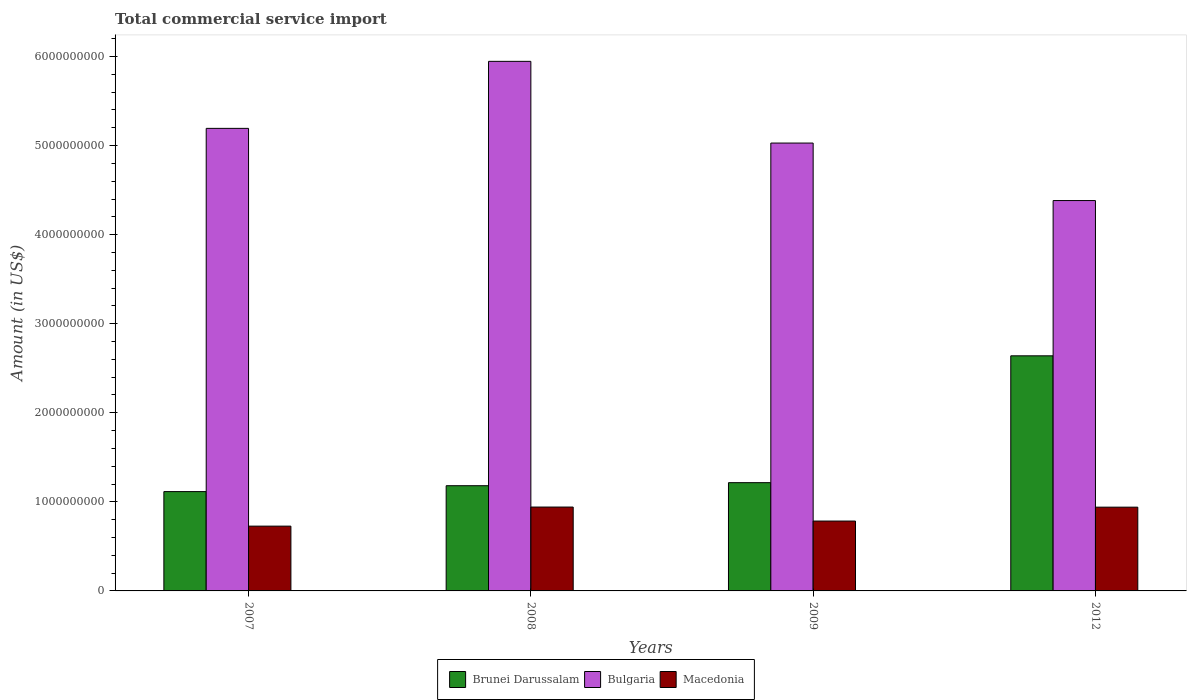Are the number of bars per tick equal to the number of legend labels?
Ensure brevity in your answer.  Yes. How many bars are there on the 3rd tick from the left?
Give a very brief answer. 3. What is the total commercial service import in Brunei Darussalam in 2007?
Ensure brevity in your answer.  1.12e+09. Across all years, what is the maximum total commercial service import in Bulgaria?
Your answer should be compact. 5.95e+09. Across all years, what is the minimum total commercial service import in Macedonia?
Offer a terse response. 7.27e+08. What is the total total commercial service import in Macedonia in the graph?
Offer a very short reply. 3.39e+09. What is the difference between the total commercial service import in Bulgaria in 2009 and that in 2012?
Your response must be concise. 6.45e+08. What is the difference between the total commercial service import in Macedonia in 2007 and the total commercial service import in Brunei Darussalam in 2009?
Your answer should be very brief. -4.88e+08. What is the average total commercial service import in Brunei Darussalam per year?
Your response must be concise. 1.54e+09. In the year 2009, what is the difference between the total commercial service import in Brunei Darussalam and total commercial service import in Macedonia?
Your response must be concise. 4.31e+08. In how many years, is the total commercial service import in Macedonia greater than 4800000000 US$?
Ensure brevity in your answer.  0. What is the ratio of the total commercial service import in Bulgaria in 2007 to that in 2012?
Keep it short and to the point. 1.18. What is the difference between the highest and the second highest total commercial service import in Brunei Darussalam?
Make the answer very short. 1.42e+09. What is the difference between the highest and the lowest total commercial service import in Macedonia?
Ensure brevity in your answer.  2.14e+08. What does the 1st bar from the left in 2009 represents?
Your response must be concise. Brunei Darussalam. What does the 1st bar from the right in 2012 represents?
Provide a short and direct response. Macedonia. How many bars are there?
Give a very brief answer. 12. How many years are there in the graph?
Your answer should be compact. 4. What is the difference between two consecutive major ticks on the Y-axis?
Make the answer very short. 1.00e+09. What is the title of the graph?
Offer a terse response. Total commercial service import. Does "Cameroon" appear as one of the legend labels in the graph?
Give a very brief answer. No. What is the Amount (in US$) in Brunei Darussalam in 2007?
Offer a terse response. 1.12e+09. What is the Amount (in US$) in Bulgaria in 2007?
Keep it short and to the point. 5.19e+09. What is the Amount (in US$) of Macedonia in 2007?
Provide a short and direct response. 7.27e+08. What is the Amount (in US$) in Brunei Darussalam in 2008?
Give a very brief answer. 1.18e+09. What is the Amount (in US$) in Bulgaria in 2008?
Your answer should be very brief. 5.95e+09. What is the Amount (in US$) of Macedonia in 2008?
Provide a succinct answer. 9.42e+08. What is the Amount (in US$) of Brunei Darussalam in 2009?
Offer a very short reply. 1.22e+09. What is the Amount (in US$) in Bulgaria in 2009?
Make the answer very short. 5.03e+09. What is the Amount (in US$) in Macedonia in 2009?
Provide a succinct answer. 7.84e+08. What is the Amount (in US$) in Brunei Darussalam in 2012?
Provide a short and direct response. 2.64e+09. What is the Amount (in US$) of Bulgaria in 2012?
Offer a very short reply. 4.38e+09. What is the Amount (in US$) of Macedonia in 2012?
Make the answer very short. 9.40e+08. Across all years, what is the maximum Amount (in US$) in Brunei Darussalam?
Your response must be concise. 2.64e+09. Across all years, what is the maximum Amount (in US$) of Bulgaria?
Ensure brevity in your answer.  5.95e+09. Across all years, what is the maximum Amount (in US$) in Macedonia?
Make the answer very short. 9.42e+08. Across all years, what is the minimum Amount (in US$) in Brunei Darussalam?
Make the answer very short. 1.12e+09. Across all years, what is the minimum Amount (in US$) in Bulgaria?
Your answer should be compact. 4.38e+09. Across all years, what is the minimum Amount (in US$) in Macedonia?
Ensure brevity in your answer.  7.27e+08. What is the total Amount (in US$) of Brunei Darussalam in the graph?
Offer a terse response. 6.15e+09. What is the total Amount (in US$) of Bulgaria in the graph?
Provide a short and direct response. 2.05e+1. What is the total Amount (in US$) in Macedonia in the graph?
Your answer should be very brief. 3.39e+09. What is the difference between the Amount (in US$) of Brunei Darussalam in 2007 and that in 2008?
Ensure brevity in your answer.  -6.61e+07. What is the difference between the Amount (in US$) of Bulgaria in 2007 and that in 2008?
Ensure brevity in your answer.  -7.52e+08. What is the difference between the Amount (in US$) of Macedonia in 2007 and that in 2008?
Give a very brief answer. -2.14e+08. What is the difference between the Amount (in US$) of Brunei Darussalam in 2007 and that in 2009?
Provide a succinct answer. -1.00e+08. What is the difference between the Amount (in US$) of Bulgaria in 2007 and that in 2009?
Give a very brief answer. 1.65e+08. What is the difference between the Amount (in US$) of Macedonia in 2007 and that in 2009?
Give a very brief answer. -5.70e+07. What is the difference between the Amount (in US$) of Brunei Darussalam in 2007 and that in 2012?
Provide a succinct answer. -1.52e+09. What is the difference between the Amount (in US$) of Bulgaria in 2007 and that in 2012?
Offer a terse response. 8.10e+08. What is the difference between the Amount (in US$) of Macedonia in 2007 and that in 2012?
Provide a succinct answer. -2.13e+08. What is the difference between the Amount (in US$) in Brunei Darussalam in 2008 and that in 2009?
Give a very brief answer. -3.43e+07. What is the difference between the Amount (in US$) in Bulgaria in 2008 and that in 2009?
Offer a very short reply. 9.17e+08. What is the difference between the Amount (in US$) in Macedonia in 2008 and that in 2009?
Keep it short and to the point. 1.57e+08. What is the difference between the Amount (in US$) of Brunei Darussalam in 2008 and that in 2012?
Make the answer very short. -1.46e+09. What is the difference between the Amount (in US$) of Bulgaria in 2008 and that in 2012?
Make the answer very short. 1.56e+09. What is the difference between the Amount (in US$) in Macedonia in 2008 and that in 2012?
Your answer should be very brief. 1.30e+06. What is the difference between the Amount (in US$) of Brunei Darussalam in 2009 and that in 2012?
Ensure brevity in your answer.  -1.42e+09. What is the difference between the Amount (in US$) in Bulgaria in 2009 and that in 2012?
Offer a terse response. 6.45e+08. What is the difference between the Amount (in US$) in Macedonia in 2009 and that in 2012?
Your answer should be compact. -1.56e+08. What is the difference between the Amount (in US$) of Brunei Darussalam in 2007 and the Amount (in US$) of Bulgaria in 2008?
Keep it short and to the point. -4.83e+09. What is the difference between the Amount (in US$) of Brunei Darussalam in 2007 and the Amount (in US$) of Macedonia in 2008?
Keep it short and to the point. 1.73e+08. What is the difference between the Amount (in US$) of Bulgaria in 2007 and the Amount (in US$) of Macedonia in 2008?
Provide a short and direct response. 4.25e+09. What is the difference between the Amount (in US$) of Brunei Darussalam in 2007 and the Amount (in US$) of Bulgaria in 2009?
Keep it short and to the point. -3.91e+09. What is the difference between the Amount (in US$) in Brunei Darussalam in 2007 and the Amount (in US$) in Macedonia in 2009?
Provide a succinct answer. 3.31e+08. What is the difference between the Amount (in US$) in Bulgaria in 2007 and the Amount (in US$) in Macedonia in 2009?
Make the answer very short. 4.41e+09. What is the difference between the Amount (in US$) in Brunei Darussalam in 2007 and the Amount (in US$) in Bulgaria in 2012?
Keep it short and to the point. -3.27e+09. What is the difference between the Amount (in US$) of Brunei Darussalam in 2007 and the Amount (in US$) of Macedonia in 2012?
Give a very brief answer. 1.75e+08. What is the difference between the Amount (in US$) in Bulgaria in 2007 and the Amount (in US$) in Macedonia in 2012?
Offer a very short reply. 4.25e+09. What is the difference between the Amount (in US$) of Brunei Darussalam in 2008 and the Amount (in US$) of Bulgaria in 2009?
Provide a short and direct response. -3.85e+09. What is the difference between the Amount (in US$) in Brunei Darussalam in 2008 and the Amount (in US$) in Macedonia in 2009?
Make the answer very short. 3.97e+08. What is the difference between the Amount (in US$) of Bulgaria in 2008 and the Amount (in US$) of Macedonia in 2009?
Your answer should be very brief. 5.16e+09. What is the difference between the Amount (in US$) in Brunei Darussalam in 2008 and the Amount (in US$) in Bulgaria in 2012?
Give a very brief answer. -3.20e+09. What is the difference between the Amount (in US$) of Brunei Darussalam in 2008 and the Amount (in US$) of Macedonia in 2012?
Your response must be concise. 2.41e+08. What is the difference between the Amount (in US$) of Bulgaria in 2008 and the Amount (in US$) of Macedonia in 2012?
Give a very brief answer. 5.01e+09. What is the difference between the Amount (in US$) of Brunei Darussalam in 2009 and the Amount (in US$) of Bulgaria in 2012?
Offer a very short reply. -3.17e+09. What is the difference between the Amount (in US$) in Brunei Darussalam in 2009 and the Amount (in US$) in Macedonia in 2012?
Make the answer very short. 2.75e+08. What is the difference between the Amount (in US$) in Bulgaria in 2009 and the Amount (in US$) in Macedonia in 2012?
Ensure brevity in your answer.  4.09e+09. What is the average Amount (in US$) in Brunei Darussalam per year?
Offer a terse response. 1.54e+09. What is the average Amount (in US$) in Bulgaria per year?
Make the answer very short. 5.14e+09. What is the average Amount (in US$) of Macedonia per year?
Make the answer very short. 8.48e+08. In the year 2007, what is the difference between the Amount (in US$) of Brunei Darussalam and Amount (in US$) of Bulgaria?
Keep it short and to the point. -4.08e+09. In the year 2007, what is the difference between the Amount (in US$) in Brunei Darussalam and Amount (in US$) in Macedonia?
Make the answer very short. 3.88e+08. In the year 2007, what is the difference between the Amount (in US$) in Bulgaria and Amount (in US$) in Macedonia?
Your response must be concise. 4.47e+09. In the year 2008, what is the difference between the Amount (in US$) of Brunei Darussalam and Amount (in US$) of Bulgaria?
Provide a succinct answer. -4.76e+09. In the year 2008, what is the difference between the Amount (in US$) of Brunei Darussalam and Amount (in US$) of Macedonia?
Make the answer very short. 2.40e+08. In the year 2008, what is the difference between the Amount (in US$) of Bulgaria and Amount (in US$) of Macedonia?
Your response must be concise. 5.00e+09. In the year 2009, what is the difference between the Amount (in US$) in Brunei Darussalam and Amount (in US$) in Bulgaria?
Ensure brevity in your answer.  -3.81e+09. In the year 2009, what is the difference between the Amount (in US$) of Brunei Darussalam and Amount (in US$) of Macedonia?
Ensure brevity in your answer.  4.31e+08. In the year 2009, what is the difference between the Amount (in US$) of Bulgaria and Amount (in US$) of Macedonia?
Your answer should be compact. 4.24e+09. In the year 2012, what is the difference between the Amount (in US$) in Brunei Darussalam and Amount (in US$) in Bulgaria?
Provide a short and direct response. -1.74e+09. In the year 2012, what is the difference between the Amount (in US$) in Brunei Darussalam and Amount (in US$) in Macedonia?
Provide a short and direct response. 1.70e+09. In the year 2012, what is the difference between the Amount (in US$) in Bulgaria and Amount (in US$) in Macedonia?
Offer a very short reply. 3.44e+09. What is the ratio of the Amount (in US$) in Brunei Darussalam in 2007 to that in 2008?
Your answer should be compact. 0.94. What is the ratio of the Amount (in US$) in Bulgaria in 2007 to that in 2008?
Your answer should be very brief. 0.87. What is the ratio of the Amount (in US$) in Macedonia in 2007 to that in 2008?
Your answer should be very brief. 0.77. What is the ratio of the Amount (in US$) in Brunei Darussalam in 2007 to that in 2009?
Make the answer very short. 0.92. What is the ratio of the Amount (in US$) of Bulgaria in 2007 to that in 2009?
Keep it short and to the point. 1.03. What is the ratio of the Amount (in US$) in Macedonia in 2007 to that in 2009?
Offer a terse response. 0.93. What is the ratio of the Amount (in US$) in Brunei Darussalam in 2007 to that in 2012?
Give a very brief answer. 0.42. What is the ratio of the Amount (in US$) of Bulgaria in 2007 to that in 2012?
Provide a succinct answer. 1.18. What is the ratio of the Amount (in US$) in Macedonia in 2007 to that in 2012?
Make the answer very short. 0.77. What is the ratio of the Amount (in US$) of Brunei Darussalam in 2008 to that in 2009?
Your response must be concise. 0.97. What is the ratio of the Amount (in US$) in Bulgaria in 2008 to that in 2009?
Your answer should be compact. 1.18. What is the ratio of the Amount (in US$) of Macedonia in 2008 to that in 2009?
Offer a very short reply. 1.2. What is the ratio of the Amount (in US$) of Brunei Darussalam in 2008 to that in 2012?
Ensure brevity in your answer.  0.45. What is the ratio of the Amount (in US$) in Bulgaria in 2008 to that in 2012?
Give a very brief answer. 1.36. What is the ratio of the Amount (in US$) of Brunei Darussalam in 2009 to that in 2012?
Offer a very short reply. 0.46. What is the ratio of the Amount (in US$) in Bulgaria in 2009 to that in 2012?
Offer a very short reply. 1.15. What is the ratio of the Amount (in US$) in Macedonia in 2009 to that in 2012?
Provide a short and direct response. 0.83. What is the difference between the highest and the second highest Amount (in US$) of Brunei Darussalam?
Make the answer very short. 1.42e+09. What is the difference between the highest and the second highest Amount (in US$) in Bulgaria?
Provide a short and direct response. 7.52e+08. What is the difference between the highest and the second highest Amount (in US$) of Macedonia?
Keep it short and to the point. 1.30e+06. What is the difference between the highest and the lowest Amount (in US$) of Brunei Darussalam?
Provide a succinct answer. 1.52e+09. What is the difference between the highest and the lowest Amount (in US$) in Bulgaria?
Your answer should be compact. 1.56e+09. What is the difference between the highest and the lowest Amount (in US$) in Macedonia?
Give a very brief answer. 2.14e+08. 